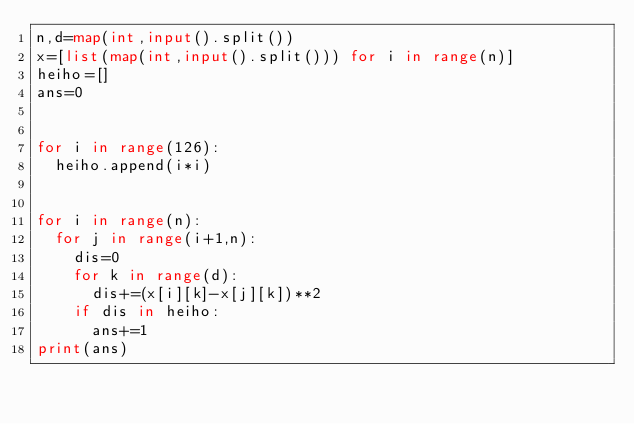Convert code to text. <code><loc_0><loc_0><loc_500><loc_500><_Python_>n,d=map(int,input().split())
x=[list(map(int,input().split())) for i in range(n)]
heiho=[]
ans=0

  
for i in range(126):
  heiho.append(i*i)


for i in range(n):
  for j in range(i+1,n):
    dis=0
    for k in range(d):
      dis+=(x[i][k]-x[j][k])**2
    if dis in heiho:
      ans+=1
print(ans)</code> 